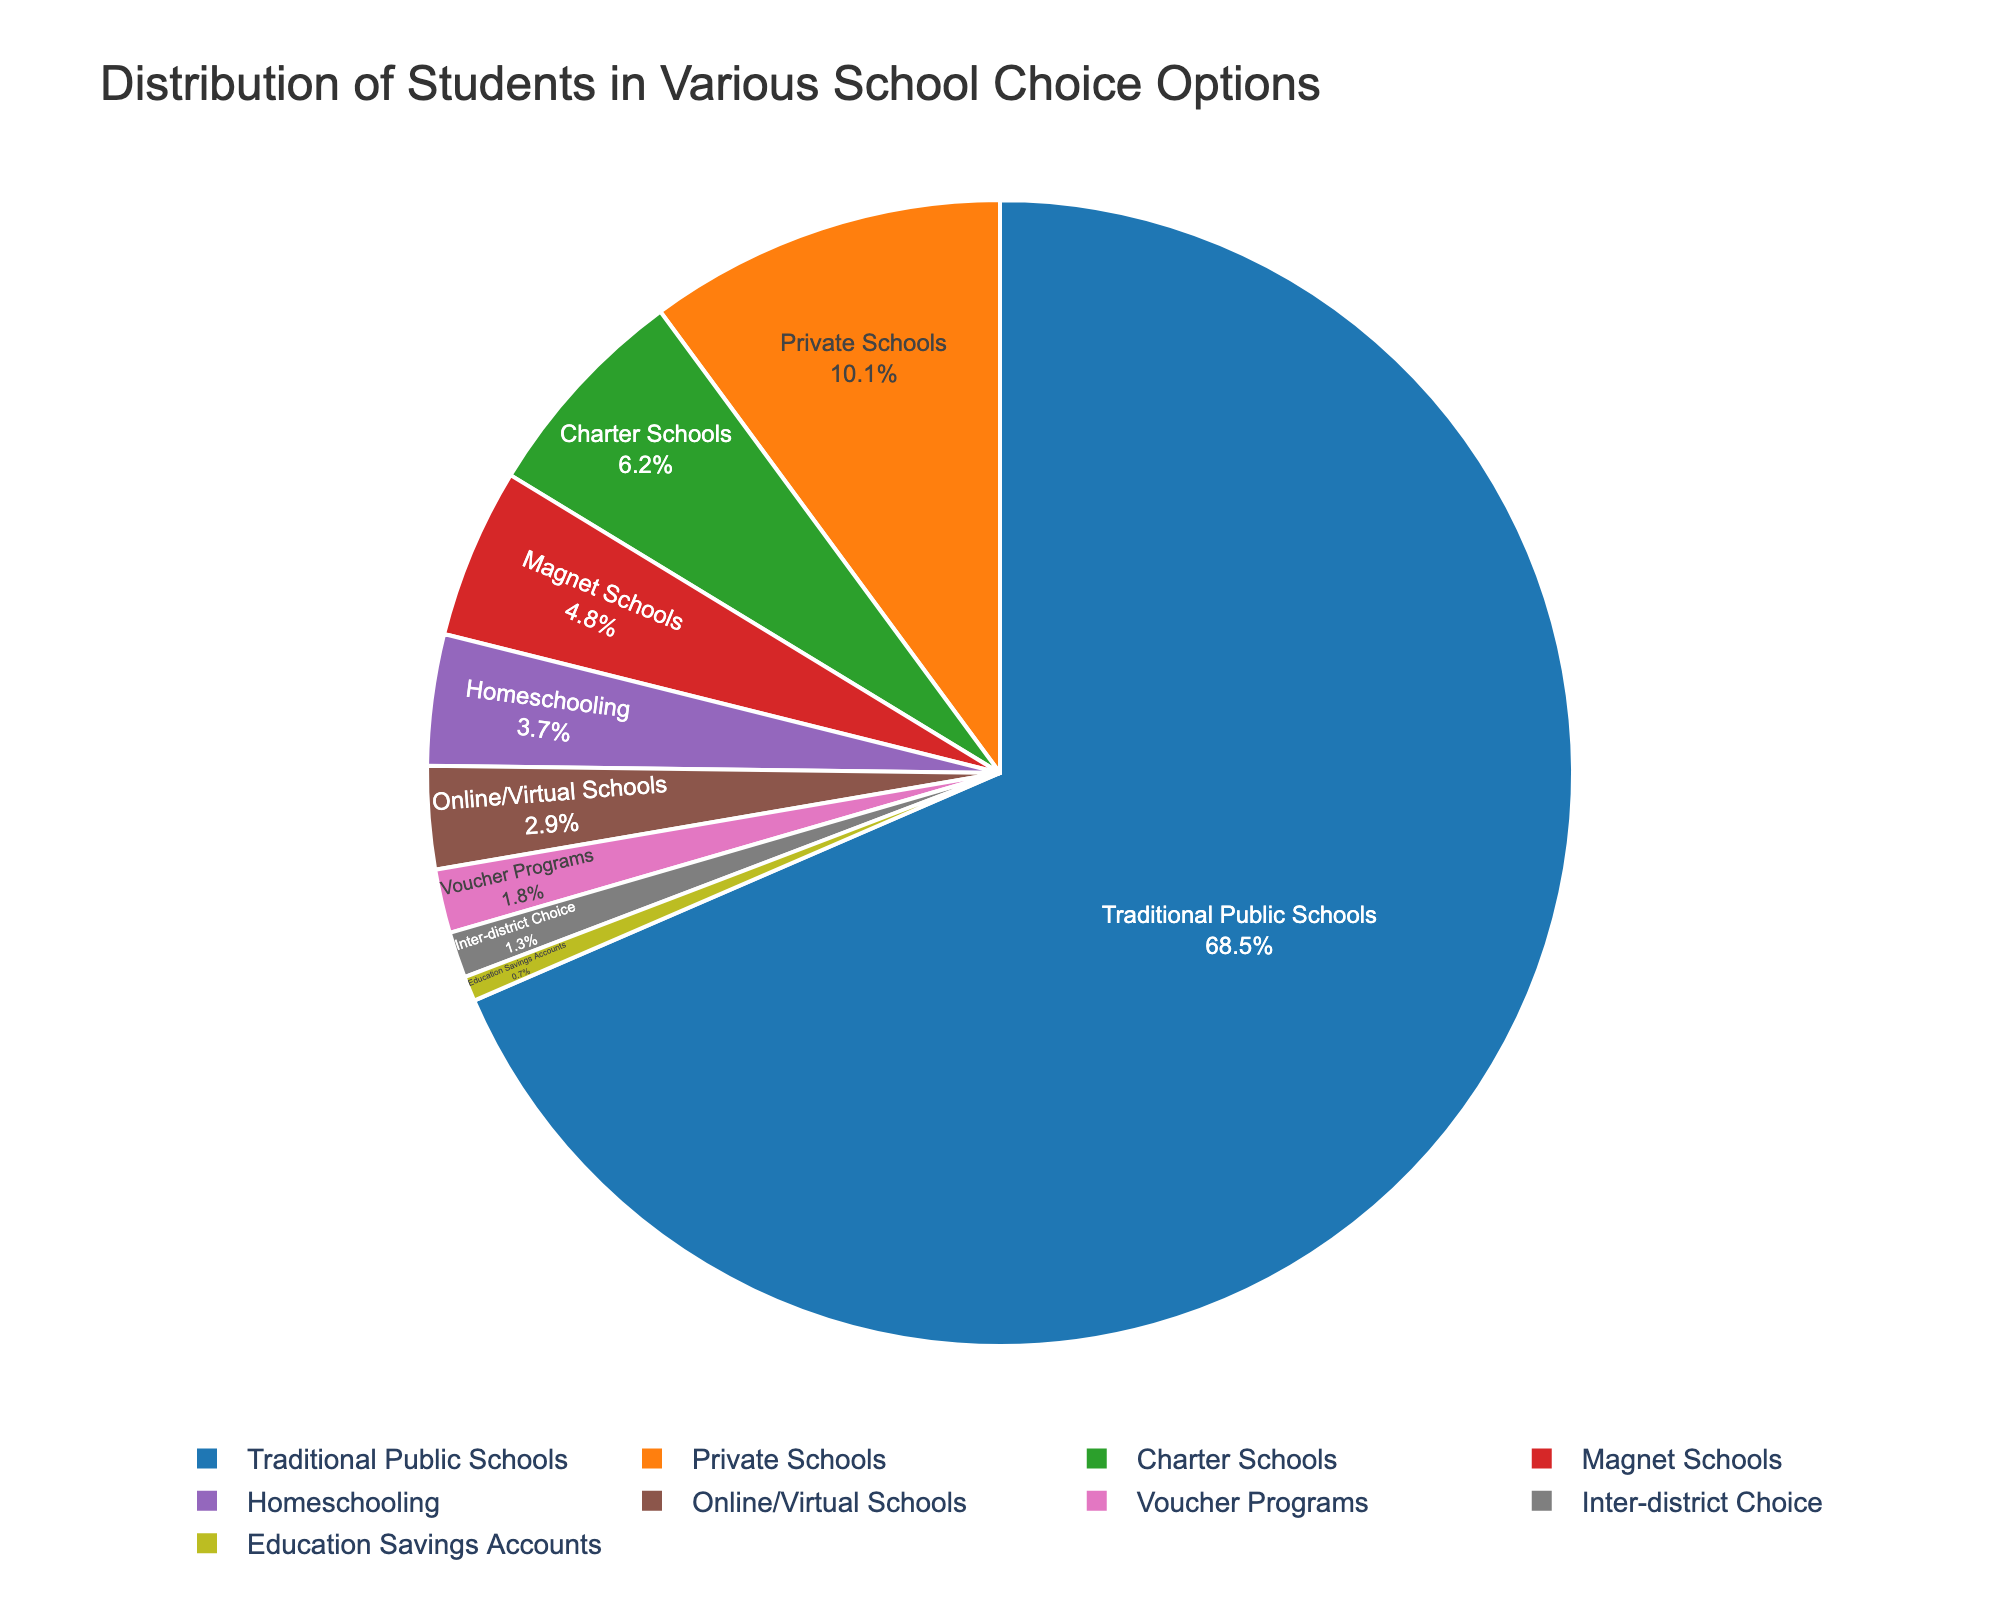what is the proportion of students enrolled in Charter Schools compared to Traditional Public Schools? The percentage of students in Charter Schools is 6.2% and in Traditional Public Schools is 68.5%. To find the proportion, divide 6.2 by 68.5. 6.2 / 68.5 ≈ 0.0905
Answer: 0.0905 Which school choice option has the smallest percentage of student enrollment? By observing the chart's data labels, the option with the smallest percentage is Education Savings Accounts at 0.7%.
Answer: Education Savings Accounts How much greater is the percentage of students in Traditional Public Schools compared to Private Schools and Homeschooling combined? Traditional Public Schools have 68.5%. Private Schools have 10.1% and Homeschooling has 3.7%. Sum the latter two and subtract from the former: 68.5 - (10.1 + 3.7) = 68.5 - 13.8 = 54.7
Answer: 54.7% Are there more students in Private Schools or Magnet Schools? Private Schools have a percentage of 10.1%, while Magnet Schools have 4.8%. Hence, Private Schools have more students.
Answer: Private Schools Which school choice option has a higher enrollment: Online/Virtual Schools or Voucher Programs? Online/Virtual Schools have 2.9% and Voucher Programs have 1.8%, so Online/Virtual Schools have a higher enrollment.
Answer: Online/Virtual Schools What is the combined percentage of students in all alternative school choice options (excluding Traditional Public Schools)? Sum all the percentages of alternative options: 6.2 + 10.1 + 3.7 + 4.8 + 2.9 + 1.8 + 0.7 + 1.3 = 31.5
Answer: 31.5% What is the difference between the percentages of students in the highest and lowest enrollment options? The highest enrollment is Traditional Public Schools at 68.5% and the lowest is Education Savings Accounts at 0.7%. The difference is 68.5 - 0.7 = 67.8
Answer: 67.8% How many options have a student enrollment percentage below 5%? From the chart, the options below 5% include Homeschooling (3.7%), Magnet Schools (4.8%), Online/Virtual Schools (2.9%), Voucher Programs (1.8%), Education Savings Accounts (0.7%), and Inter-district Choice (1.3%). There are 6 options.
Answer: 6 If we combine the percentages of students in Charter Schools and Online/Virtual Schools, what percentage would this represent? Add the percentages of Charter Schools (6.2%) and Online/Virtual Schools (2.9%): 6.2 + 2.9 = 9.1
Answer: 9.1% 